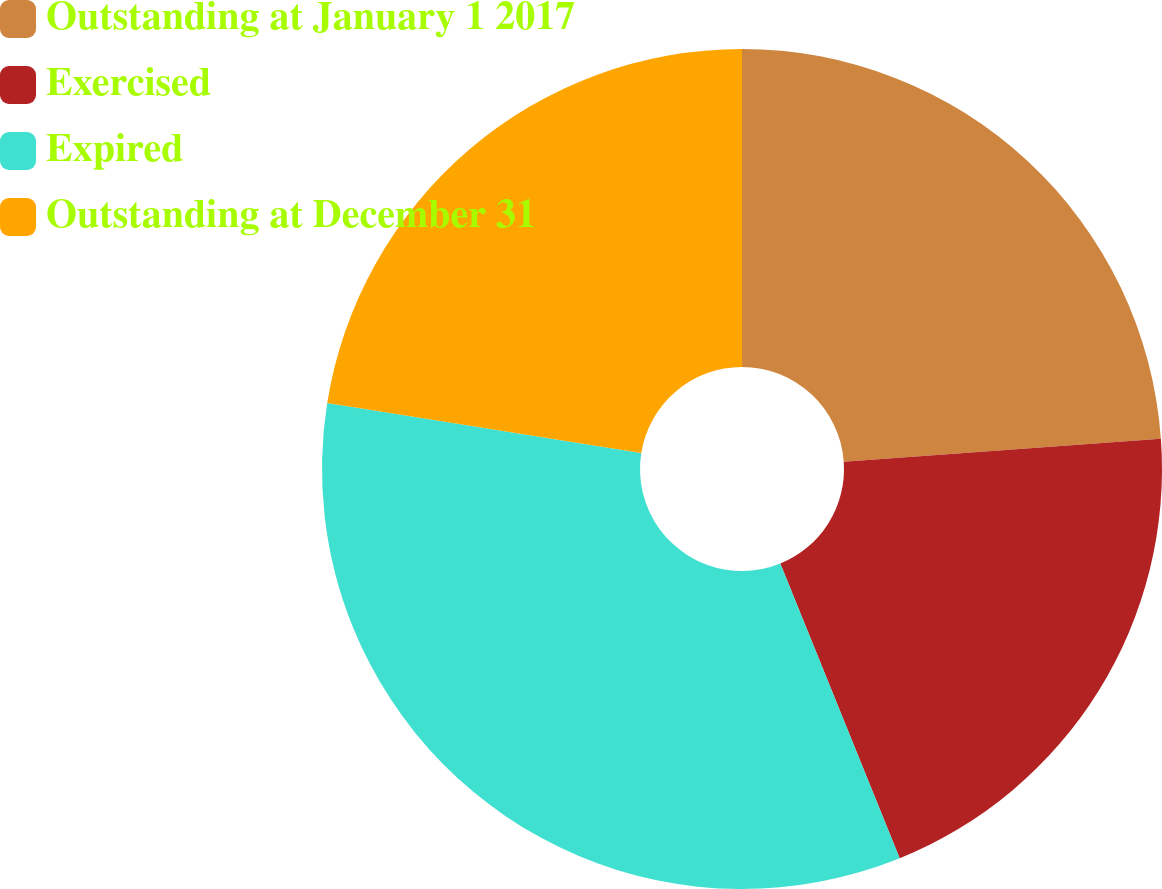Convert chart. <chart><loc_0><loc_0><loc_500><loc_500><pie_chart><fcel>Outstanding at January 1 2017<fcel>Exercised<fcel>Expired<fcel>Outstanding at December 31<nl><fcel>23.85%<fcel>20.02%<fcel>33.63%<fcel>22.49%<nl></chart> 